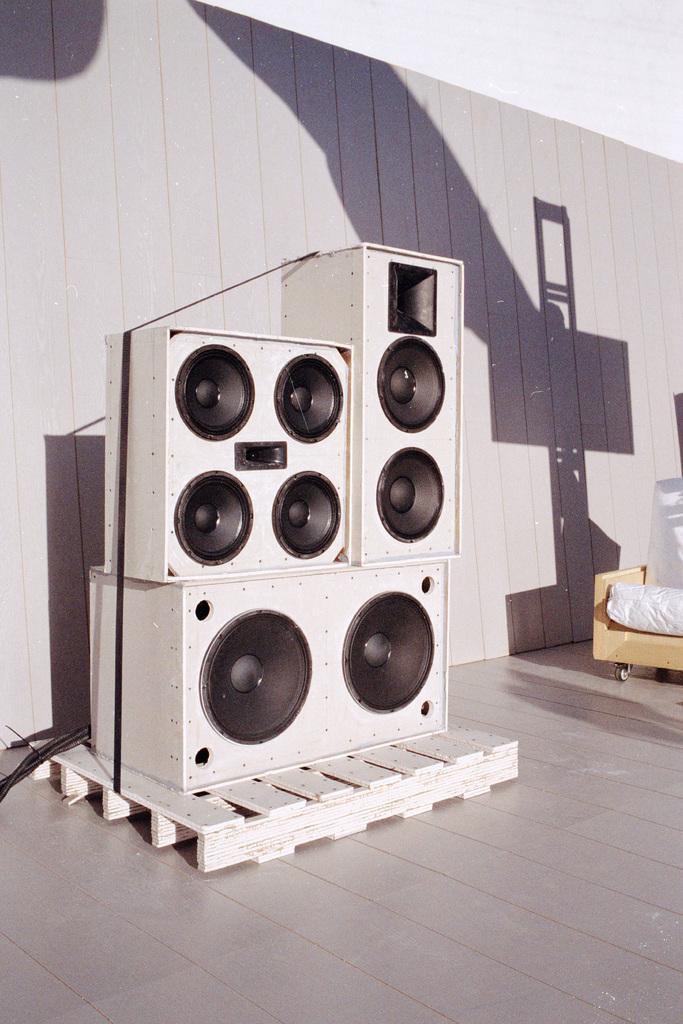How would you summarize this image in a sentence or two? In this image, we can see some speakers on a wooden object. We can also see some objects on the right. We can also see the wall with the shadow. We can also see some wires on the left. We can see the ground. 